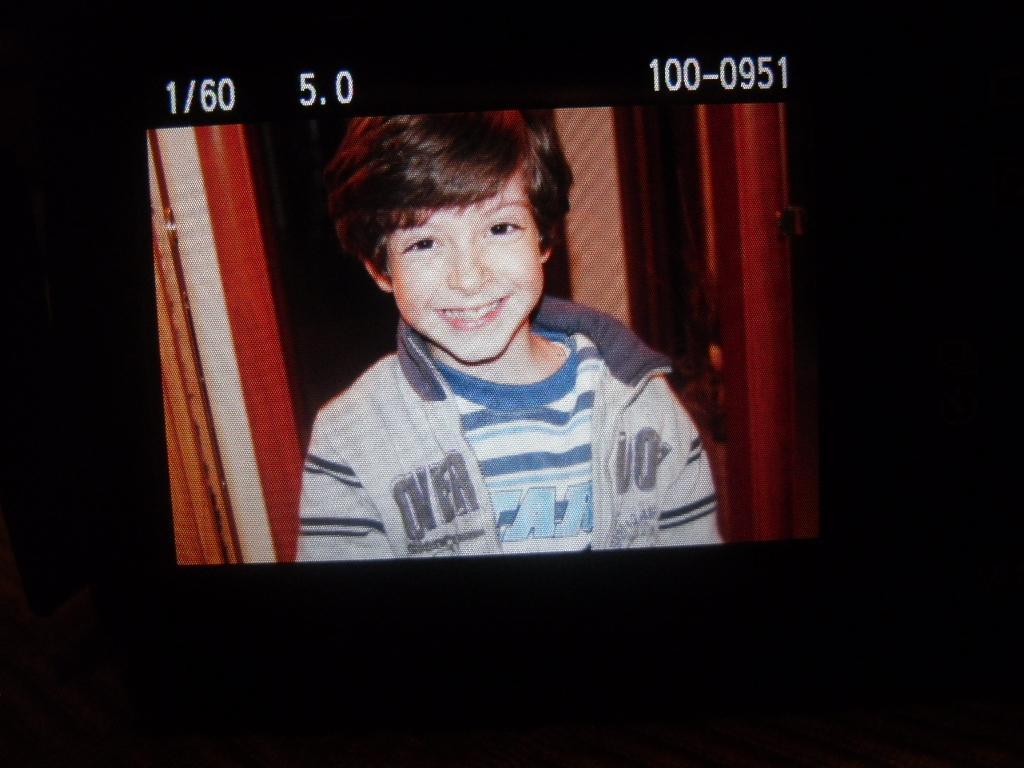In one or two sentences, can you explain what this image depicts? In this image I can see a boy is laughing, he wore t-shirt and a sweater. At the top there are numbers. 